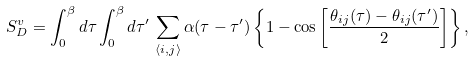<formula> <loc_0><loc_0><loc_500><loc_500>S _ { D } ^ { v } = \int _ { 0 } ^ { \beta } d \tau \int _ { 0 } ^ { \beta } d \tau ^ { \prime } \, \sum _ { \langle i , j \rangle } \alpha ( \tau - \tau ^ { \prime } ) \left \{ 1 - \cos \left [ \frac { \theta _ { i j } ( \tau ) - \theta _ { i j } ( \tau ^ { \prime } ) } { 2 } \right ] \right \} ,</formula> 